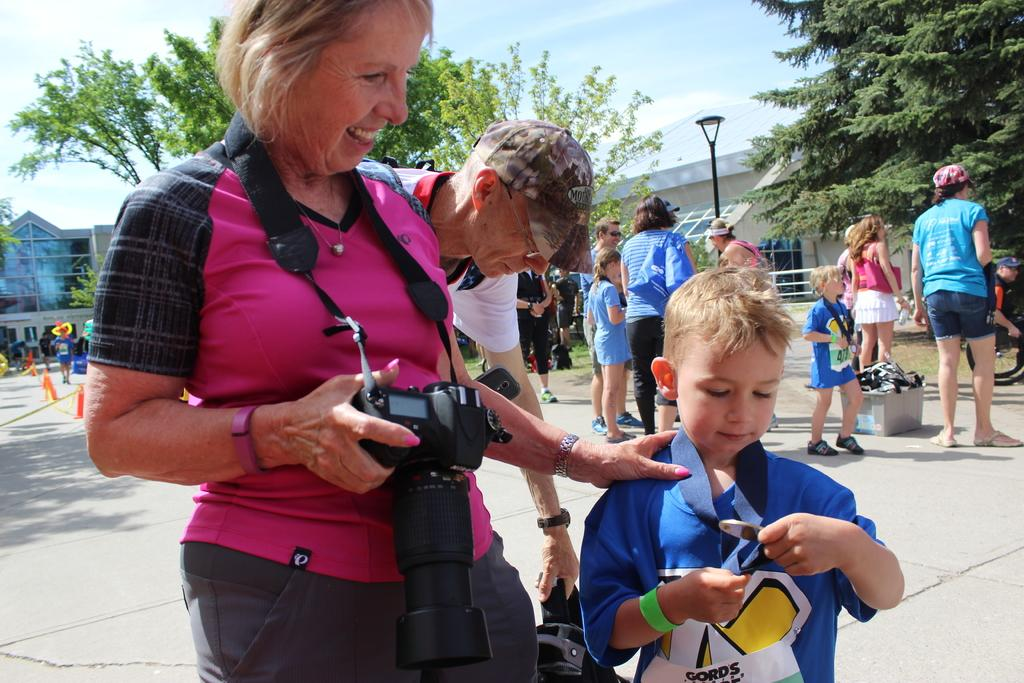What is happening in the image involving people? There are people standing in the image, and a woman is holding a camera with a child. What can be seen in the background of the image? There are trees, the sky, and lights visible in the background of the image. What shape is the brain of the child in the image? There is no visible brain in the image, as the child is not shown without a head. 